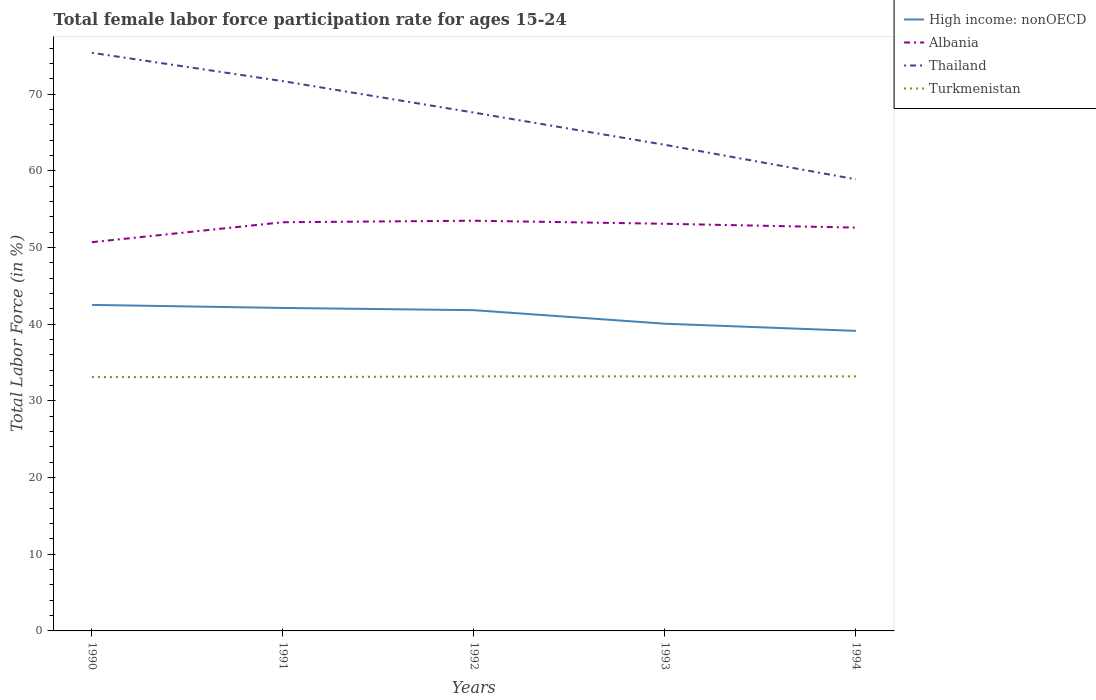How many different coloured lines are there?
Keep it short and to the point. 4. Does the line corresponding to High income: nonOECD intersect with the line corresponding to Albania?
Your answer should be compact. No. Is the number of lines equal to the number of legend labels?
Your answer should be very brief. Yes. Across all years, what is the maximum female labor force participation rate in High income: nonOECD?
Make the answer very short. 39.13. In which year was the female labor force participation rate in Thailand maximum?
Offer a very short reply. 1994. What is the total female labor force participation rate in Thailand in the graph?
Keep it short and to the point. 12. What is the difference between the highest and the second highest female labor force participation rate in Albania?
Give a very brief answer. 2.8. What is the difference between the highest and the lowest female labor force participation rate in Turkmenistan?
Offer a very short reply. 3. Is the female labor force participation rate in Albania strictly greater than the female labor force participation rate in Turkmenistan over the years?
Make the answer very short. No. How many years are there in the graph?
Provide a succinct answer. 5. How many legend labels are there?
Give a very brief answer. 4. What is the title of the graph?
Offer a terse response. Total female labor force participation rate for ages 15-24. Does "Saudi Arabia" appear as one of the legend labels in the graph?
Make the answer very short. No. What is the Total Labor Force (in %) of High income: nonOECD in 1990?
Offer a very short reply. 42.52. What is the Total Labor Force (in %) of Albania in 1990?
Ensure brevity in your answer.  50.7. What is the Total Labor Force (in %) in Thailand in 1990?
Offer a very short reply. 75.4. What is the Total Labor Force (in %) in Turkmenistan in 1990?
Your response must be concise. 33.1. What is the Total Labor Force (in %) in High income: nonOECD in 1991?
Your answer should be compact. 42.12. What is the Total Labor Force (in %) of Albania in 1991?
Offer a terse response. 53.3. What is the Total Labor Force (in %) of Thailand in 1991?
Your response must be concise. 71.7. What is the Total Labor Force (in %) in Turkmenistan in 1991?
Keep it short and to the point. 33.1. What is the Total Labor Force (in %) of High income: nonOECD in 1992?
Offer a very short reply. 41.83. What is the Total Labor Force (in %) in Albania in 1992?
Provide a succinct answer. 53.5. What is the Total Labor Force (in %) of Thailand in 1992?
Ensure brevity in your answer.  67.6. What is the Total Labor Force (in %) in Turkmenistan in 1992?
Give a very brief answer. 33.2. What is the Total Labor Force (in %) in High income: nonOECD in 1993?
Ensure brevity in your answer.  40.07. What is the Total Labor Force (in %) in Albania in 1993?
Give a very brief answer. 53.1. What is the Total Labor Force (in %) of Thailand in 1993?
Ensure brevity in your answer.  63.4. What is the Total Labor Force (in %) in Turkmenistan in 1993?
Your answer should be very brief. 33.2. What is the Total Labor Force (in %) in High income: nonOECD in 1994?
Your answer should be very brief. 39.13. What is the Total Labor Force (in %) of Albania in 1994?
Give a very brief answer. 52.6. What is the Total Labor Force (in %) of Thailand in 1994?
Offer a very short reply. 58.9. What is the Total Labor Force (in %) of Turkmenistan in 1994?
Give a very brief answer. 33.2. Across all years, what is the maximum Total Labor Force (in %) of High income: nonOECD?
Make the answer very short. 42.52. Across all years, what is the maximum Total Labor Force (in %) of Albania?
Make the answer very short. 53.5. Across all years, what is the maximum Total Labor Force (in %) of Thailand?
Your response must be concise. 75.4. Across all years, what is the maximum Total Labor Force (in %) of Turkmenistan?
Offer a terse response. 33.2. Across all years, what is the minimum Total Labor Force (in %) in High income: nonOECD?
Offer a terse response. 39.13. Across all years, what is the minimum Total Labor Force (in %) of Albania?
Ensure brevity in your answer.  50.7. Across all years, what is the minimum Total Labor Force (in %) in Thailand?
Provide a succinct answer. 58.9. Across all years, what is the minimum Total Labor Force (in %) of Turkmenistan?
Your answer should be very brief. 33.1. What is the total Total Labor Force (in %) of High income: nonOECD in the graph?
Offer a very short reply. 205.67. What is the total Total Labor Force (in %) in Albania in the graph?
Offer a terse response. 263.2. What is the total Total Labor Force (in %) in Thailand in the graph?
Give a very brief answer. 337. What is the total Total Labor Force (in %) in Turkmenistan in the graph?
Provide a short and direct response. 165.8. What is the difference between the Total Labor Force (in %) in High income: nonOECD in 1990 and that in 1991?
Provide a succinct answer. 0.39. What is the difference between the Total Labor Force (in %) in Thailand in 1990 and that in 1991?
Your answer should be compact. 3.7. What is the difference between the Total Labor Force (in %) of Turkmenistan in 1990 and that in 1991?
Your answer should be compact. 0. What is the difference between the Total Labor Force (in %) in High income: nonOECD in 1990 and that in 1992?
Your answer should be compact. 0.69. What is the difference between the Total Labor Force (in %) of Albania in 1990 and that in 1992?
Keep it short and to the point. -2.8. What is the difference between the Total Labor Force (in %) in High income: nonOECD in 1990 and that in 1993?
Your response must be concise. 2.45. What is the difference between the Total Labor Force (in %) in High income: nonOECD in 1990 and that in 1994?
Provide a succinct answer. 3.39. What is the difference between the Total Labor Force (in %) in Thailand in 1990 and that in 1994?
Offer a very short reply. 16.5. What is the difference between the Total Labor Force (in %) in High income: nonOECD in 1991 and that in 1992?
Provide a short and direct response. 0.29. What is the difference between the Total Labor Force (in %) in Thailand in 1991 and that in 1992?
Provide a short and direct response. 4.1. What is the difference between the Total Labor Force (in %) of Turkmenistan in 1991 and that in 1992?
Your answer should be very brief. -0.1. What is the difference between the Total Labor Force (in %) in High income: nonOECD in 1991 and that in 1993?
Provide a succinct answer. 2.06. What is the difference between the Total Labor Force (in %) in Albania in 1991 and that in 1993?
Ensure brevity in your answer.  0.2. What is the difference between the Total Labor Force (in %) in Thailand in 1991 and that in 1993?
Make the answer very short. 8.3. What is the difference between the Total Labor Force (in %) in High income: nonOECD in 1991 and that in 1994?
Give a very brief answer. 2.99. What is the difference between the Total Labor Force (in %) of Thailand in 1991 and that in 1994?
Offer a terse response. 12.8. What is the difference between the Total Labor Force (in %) in High income: nonOECD in 1992 and that in 1993?
Ensure brevity in your answer.  1.77. What is the difference between the Total Labor Force (in %) in Albania in 1992 and that in 1993?
Give a very brief answer. 0.4. What is the difference between the Total Labor Force (in %) of Turkmenistan in 1992 and that in 1993?
Your answer should be very brief. 0. What is the difference between the Total Labor Force (in %) of High income: nonOECD in 1992 and that in 1994?
Ensure brevity in your answer.  2.7. What is the difference between the Total Labor Force (in %) of Thailand in 1992 and that in 1994?
Offer a terse response. 8.7. What is the difference between the Total Labor Force (in %) in High income: nonOECD in 1993 and that in 1994?
Provide a succinct answer. 0.93. What is the difference between the Total Labor Force (in %) in Albania in 1993 and that in 1994?
Provide a short and direct response. 0.5. What is the difference between the Total Labor Force (in %) in Thailand in 1993 and that in 1994?
Your answer should be very brief. 4.5. What is the difference between the Total Labor Force (in %) in Turkmenistan in 1993 and that in 1994?
Your response must be concise. 0. What is the difference between the Total Labor Force (in %) of High income: nonOECD in 1990 and the Total Labor Force (in %) of Albania in 1991?
Provide a short and direct response. -10.78. What is the difference between the Total Labor Force (in %) of High income: nonOECD in 1990 and the Total Labor Force (in %) of Thailand in 1991?
Give a very brief answer. -29.18. What is the difference between the Total Labor Force (in %) of High income: nonOECD in 1990 and the Total Labor Force (in %) of Turkmenistan in 1991?
Provide a succinct answer. 9.42. What is the difference between the Total Labor Force (in %) in Albania in 1990 and the Total Labor Force (in %) in Thailand in 1991?
Provide a succinct answer. -21. What is the difference between the Total Labor Force (in %) in Thailand in 1990 and the Total Labor Force (in %) in Turkmenistan in 1991?
Offer a very short reply. 42.3. What is the difference between the Total Labor Force (in %) in High income: nonOECD in 1990 and the Total Labor Force (in %) in Albania in 1992?
Provide a succinct answer. -10.98. What is the difference between the Total Labor Force (in %) of High income: nonOECD in 1990 and the Total Labor Force (in %) of Thailand in 1992?
Your response must be concise. -25.08. What is the difference between the Total Labor Force (in %) in High income: nonOECD in 1990 and the Total Labor Force (in %) in Turkmenistan in 1992?
Ensure brevity in your answer.  9.32. What is the difference between the Total Labor Force (in %) of Albania in 1990 and the Total Labor Force (in %) of Thailand in 1992?
Your answer should be very brief. -16.9. What is the difference between the Total Labor Force (in %) in Albania in 1990 and the Total Labor Force (in %) in Turkmenistan in 1992?
Your answer should be compact. 17.5. What is the difference between the Total Labor Force (in %) in Thailand in 1990 and the Total Labor Force (in %) in Turkmenistan in 1992?
Your response must be concise. 42.2. What is the difference between the Total Labor Force (in %) in High income: nonOECD in 1990 and the Total Labor Force (in %) in Albania in 1993?
Make the answer very short. -10.58. What is the difference between the Total Labor Force (in %) of High income: nonOECD in 1990 and the Total Labor Force (in %) of Thailand in 1993?
Offer a very short reply. -20.88. What is the difference between the Total Labor Force (in %) in High income: nonOECD in 1990 and the Total Labor Force (in %) in Turkmenistan in 1993?
Make the answer very short. 9.32. What is the difference between the Total Labor Force (in %) in Albania in 1990 and the Total Labor Force (in %) in Thailand in 1993?
Provide a short and direct response. -12.7. What is the difference between the Total Labor Force (in %) in Thailand in 1990 and the Total Labor Force (in %) in Turkmenistan in 1993?
Keep it short and to the point. 42.2. What is the difference between the Total Labor Force (in %) of High income: nonOECD in 1990 and the Total Labor Force (in %) of Albania in 1994?
Your response must be concise. -10.08. What is the difference between the Total Labor Force (in %) in High income: nonOECD in 1990 and the Total Labor Force (in %) in Thailand in 1994?
Give a very brief answer. -16.38. What is the difference between the Total Labor Force (in %) of High income: nonOECD in 1990 and the Total Labor Force (in %) of Turkmenistan in 1994?
Offer a very short reply. 9.32. What is the difference between the Total Labor Force (in %) of Albania in 1990 and the Total Labor Force (in %) of Thailand in 1994?
Make the answer very short. -8.2. What is the difference between the Total Labor Force (in %) in Thailand in 1990 and the Total Labor Force (in %) in Turkmenistan in 1994?
Provide a short and direct response. 42.2. What is the difference between the Total Labor Force (in %) in High income: nonOECD in 1991 and the Total Labor Force (in %) in Albania in 1992?
Offer a very short reply. -11.38. What is the difference between the Total Labor Force (in %) in High income: nonOECD in 1991 and the Total Labor Force (in %) in Thailand in 1992?
Provide a succinct answer. -25.48. What is the difference between the Total Labor Force (in %) in High income: nonOECD in 1991 and the Total Labor Force (in %) in Turkmenistan in 1992?
Offer a very short reply. 8.92. What is the difference between the Total Labor Force (in %) in Albania in 1991 and the Total Labor Force (in %) in Thailand in 1992?
Ensure brevity in your answer.  -14.3. What is the difference between the Total Labor Force (in %) of Albania in 1991 and the Total Labor Force (in %) of Turkmenistan in 1992?
Give a very brief answer. 20.1. What is the difference between the Total Labor Force (in %) of Thailand in 1991 and the Total Labor Force (in %) of Turkmenistan in 1992?
Provide a short and direct response. 38.5. What is the difference between the Total Labor Force (in %) of High income: nonOECD in 1991 and the Total Labor Force (in %) of Albania in 1993?
Keep it short and to the point. -10.98. What is the difference between the Total Labor Force (in %) in High income: nonOECD in 1991 and the Total Labor Force (in %) in Thailand in 1993?
Offer a very short reply. -21.28. What is the difference between the Total Labor Force (in %) in High income: nonOECD in 1991 and the Total Labor Force (in %) in Turkmenistan in 1993?
Keep it short and to the point. 8.92. What is the difference between the Total Labor Force (in %) in Albania in 1991 and the Total Labor Force (in %) in Turkmenistan in 1993?
Provide a short and direct response. 20.1. What is the difference between the Total Labor Force (in %) in Thailand in 1991 and the Total Labor Force (in %) in Turkmenistan in 1993?
Keep it short and to the point. 38.5. What is the difference between the Total Labor Force (in %) of High income: nonOECD in 1991 and the Total Labor Force (in %) of Albania in 1994?
Provide a succinct answer. -10.48. What is the difference between the Total Labor Force (in %) in High income: nonOECD in 1991 and the Total Labor Force (in %) in Thailand in 1994?
Your answer should be compact. -16.78. What is the difference between the Total Labor Force (in %) in High income: nonOECD in 1991 and the Total Labor Force (in %) in Turkmenistan in 1994?
Keep it short and to the point. 8.92. What is the difference between the Total Labor Force (in %) of Albania in 1991 and the Total Labor Force (in %) of Thailand in 1994?
Offer a terse response. -5.6. What is the difference between the Total Labor Force (in %) in Albania in 1991 and the Total Labor Force (in %) in Turkmenistan in 1994?
Offer a terse response. 20.1. What is the difference between the Total Labor Force (in %) of Thailand in 1991 and the Total Labor Force (in %) of Turkmenistan in 1994?
Keep it short and to the point. 38.5. What is the difference between the Total Labor Force (in %) of High income: nonOECD in 1992 and the Total Labor Force (in %) of Albania in 1993?
Keep it short and to the point. -11.27. What is the difference between the Total Labor Force (in %) of High income: nonOECD in 1992 and the Total Labor Force (in %) of Thailand in 1993?
Your answer should be compact. -21.57. What is the difference between the Total Labor Force (in %) of High income: nonOECD in 1992 and the Total Labor Force (in %) of Turkmenistan in 1993?
Your answer should be very brief. 8.63. What is the difference between the Total Labor Force (in %) in Albania in 1992 and the Total Labor Force (in %) in Turkmenistan in 1993?
Offer a terse response. 20.3. What is the difference between the Total Labor Force (in %) in Thailand in 1992 and the Total Labor Force (in %) in Turkmenistan in 1993?
Provide a succinct answer. 34.4. What is the difference between the Total Labor Force (in %) in High income: nonOECD in 1992 and the Total Labor Force (in %) in Albania in 1994?
Ensure brevity in your answer.  -10.77. What is the difference between the Total Labor Force (in %) in High income: nonOECD in 1992 and the Total Labor Force (in %) in Thailand in 1994?
Keep it short and to the point. -17.07. What is the difference between the Total Labor Force (in %) in High income: nonOECD in 1992 and the Total Labor Force (in %) in Turkmenistan in 1994?
Your answer should be compact. 8.63. What is the difference between the Total Labor Force (in %) in Albania in 1992 and the Total Labor Force (in %) in Turkmenistan in 1994?
Offer a terse response. 20.3. What is the difference between the Total Labor Force (in %) in Thailand in 1992 and the Total Labor Force (in %) in Turkmenistan in 1994?
Ensure brevity in your answer.  34.4. What is the difference between the Total Labor Force (in %) of High income: nonOECD in 1993 and the Total Labor Force (in %) of Albania in 1994?
Provide a short and direct response. -12.53. What is the difference between the Total Labor Force (in %) in High income: nonOECD in 1993 and the Total Labor Force (in %) in Thailand in 1994?
Ensure brevity in your answer.  -18.83. What is the difference between the Total Labor Force (in %) in High income: nonOECD in 1993 and the Total Labor Force (in %) in Turkmenistan in 1994?
Keep it short and to the point. 6.87. What is the difference between the Total Labor Force (in %) in Albania in 1993 and the Total Labor Force (in %) in Turkmenistan in 1994?
Your response must be concise. 19.9. What is the difference between the Total Labor Force (in %) of Thailand in 1993 and the Total Labor Force (in %) of Turkmenistan in 1994?
Your response must be concise. 30.2. What is the average Total Labor Force (in %) in High income: nonOECD per year?
Offer a terse response. 41.13. What is the average Total Labor Force (in %) in Albania per year?
Give a very brief answer. 52.64. What is the average Total Labor Force (in %) in Thailand per year?
Your answer should be very brief. 67.4. What is the average Total Labor Force (in %) in Turkmenistan per year?
Keep it short and to the point. 33.16. In the year 1990, what is the difference between the Total Labor Force (in %) of High income: nonOECD and Total Labor Force (in %) of Albania?
Keep it short and to the point. -8.18. In the year 1990, what is the difference between the Total Labor Force (in %) of High income: nonOECD and Total Labor Force (in %) of Thailand?
Your answer should be compact. -32.88. In the year 1990, what is the difference between the Total Labor Force (in %) of High income: nonOECD and Total Labor Force (in %) of Turkmenistan?
Your answer should be compact. 9.42. In the year 1990, what is the difference between the Total Labor Force (in %) of Albania and Total Labor Force (in %) of Thailand?
Offer a terse response. -24.7. In the year 1990, what is the difference between the Total Labor Force (in %) of Albania and Total Labor Force (in %) of Turkmenistan?
Your answer should be very brief. 17.6. In the year 1990, what is the difference between the Total Labor Force (in %) of Thailand and Total Labor Force (in %) of Turkmenistan?
Provide a succinct answer. 42.3. In the year 1991, what is the difference between the Total Labor Force (in %) in High income: nonOECD and Total Labor Force (in %) in Albania?
Your answer should be very brief. -11.18. In the year 1991, what is the difference between the Total Labor Force (in %) of High income: nonOECD and Total Labor Force (in %) of Thailand?
Provide a short and direct response. -29.58. In the year 1991, what is the difference between the Total Labor Force (in %) in High income: nonOECD and Total Labor Force (in %) in Turkmenistan?
Offer a very short reply. 9.02. In the year 1991, what is the difference between the Total Labor Force (in %) of Albania and Total Labor Force (in %) of Thailand?
Your response must be concise. -18.4. In the year 1991, what is the difference between the Total Labor Force (in %) of Albania and Total Labor Force (in %) of Turkmenistan?
Give a very brief answer. 20.2. In the year 1991, what is the difference between the Total Labor Force (in %) of Thailand and Total Labor Force (in %) of Turkmenistan?
Ensure brevity in your answer.  38.6. In the year 1992, what is the difference between the Total Labor Force (in %) in High income: nonOECD and Total Labor Force (in %) in Albania?
Your response must be concise. -11.67. In the year 1992, what is the difference between the Total Labor Force (in %) in High income: nonOECD and Total Labor Force (in %) in Thailand?
Offer a terse response. -25.77. In the year 1992, what is the difference between the Total Labor Force (in %) in High income: nonOECD and Total Labor Force (in %) in Turkmenistan?
Offer a terse response. 8.63. In the year 1992, what is the difference between the Total Labor Force (in %) in Albania and Total Labor Force (in %) in Thailand?
Offer a terse response. -14.1. In the year 1992, what is the difference between the Total Labor Force (in %) of Albania and Total Labor Force (in %) of Turkmenistan?
Your answer should be very brief. 20.3. In the year 1992, what is the difference between the Total Labor Force (in %) of Thailand and Total Labor Force (in %) of Turkmenistan?
Your answer should be compact. 34.4. In the year 1993, what is the difference between the Total Labor Force (in %) of High income: nonOECD and Total Labor Force (in %) of Albania?
Provide a succinct answer. -13.03. In the year 1993, what is the difference between the Total Labor Force (in %) of High income: nonOECD and Total Labor Force (in %) of Thailand?
Provide a succinct answer. -23.33. In the year 1993, what is the difference between the Total Labor Force (in %) in High income: nonOECD and Total Labor Force (in %) in Turkmenistan?
Your answer should be very brief. 6.87. In the year 1993, what is the difference between the Total Labor Force (in %) in Albania and Total Labor Force (in %) in Thailand?
Your response must be concise. -10.3. In the year 1993, what is the difference between the Total Labor Force (in %) in Thailand and Total Labor Force (in %) in Turkmenistan?
Provide a succinct answer. 30.2. In the year 1994, what is the difference between the Total Labor Force (in %) of High income: nonOECD and Total Labor Force (in %) of Albania?
Your response must be concise. -13.47. In the year 1994, what is the difference between the Total Labor Force (in %) of High income: nonOECD and Total Labor Force (in %) of Thailand?
Your answer should be compact. -19.77. In the year 1994, what is the difference between the Total Labor Force (in %) of High income: nonOECD and Total Labor Force (in %) of Turkmenistan?
Make the answer very short. 5.93. In the year 1994, what is the difference between the Total Labor Force (in %) of Albania and Total Labor Force (in %) of Thailand?
Offer a very short reply. -6.3. In the year 1994, what is the difference between the Total Labor Force (in %) in Albania and Total Labor Force (in %) in Turkmenistan?
Ensure brevity in your answer.  19.4. In the year 1994, what is the difference between the Total Labor Force (in %) of Thailand and Total Labor Force (in %) of Turkmenistan?
Offer a terse response. 25.7. What is the ratio of the Total Labor Force (in %) in High income: nonOECD in 1990 to that in 1991?
Provide a short and direct response. 1.01. What is the ratio of the Total Labor Force (in %) in Albania in 1990 to that in 1991?
Provide a short and direct response. 0.95. What is the ratio of the Total Labor Force (in %) in Thailand in 1990 to that in 1991?
Make the answer very short. 1.05. What is the ratio of the Total Labor Force (in %) of Turkmenistan in 1990 to that in 1991?
Offer a terse response. 1. What is the ratio of the Total Labor Force (in %) in High income: nonOECD in 1990 to that in 1992?
Make the answer very short. 1.02. What is the ratio of the Total Labor Force (in %) in Albania in 1990 to that in 1992?
Offer a terse response. 0.95. What is the ratio of the Total Labor Force (in %) of Thailand in 1990 to that in 1992?
Make the answer very short. 1.12. What is the ratio of the Total Labor Force (in %) of High income: nonOECD in 1990 to that in 1993?
Offer a terse response. 1.06. What is the ratio of the Total Labor Force (in %) in Albania in 1990 to that in 1993?
Your answer should be very brief. 0.95. What is the ratio of the Total Labor Force (in %) in Thailand in 1990 to that in 1993?
Your answer should be compact. 1.19. What is the ratio of the Total Labor Force (in %) of Turkmenistan in 1990 to that in 1993?
Provide a short and direct response. 1. What is the ratio of the Total Labor Force (in %) in High income: nonOECD in 1990 to that in 1994?
Your response must be concise. 1.09. What is the ratio of the Total Labor Force (in %) in Albania in 1990 to that in 1994?
Make the answer very short. 0.96. What is the ratio of the Total Labor Force (in %) of Thailand in 1990 to that in 1994?
Offer a terse response. 1.28. What is the ratio of the Total Labor Force (in %) of High income: nonOECD in 1991 to that in 1992?
Keep it short and to the point. 1.01. What is the ratio of the Total Labor Force (in %) in Thailand in 1991 to that in 1992?
Provide a succinct answer. 1.06. What is the ratio of the Total Labor Force (in %) in High income: nonOECD in 1991 to that in 1993?
Provide a short and direct response. 1.05. What is the ratio of the Total Labor Force (in %) of Albania in 1991 to that in 1993?
Offer a terse response. 1. What is the ratio of the Total Labor Force (in %) of Thailand in 1991 to that in 1993?
Provide a short and direct response. 1.13. What is the ratio of the Total Labor Force (in %) of Turkmenistan in 1991 to that in 1993?
Provide a short and direct response. 1. What is the ratio of the Total Labor Force (in %) of High income: nonOECD in 1991 to that in 1994?
Ensure brevity in your answer.  1.08. What is the ratio of the Total Labor Force (in %) of Albania in 1991 to that in 1994?
Give a very brief answer. 1.01. What is the ratio of the Total Labor Force (in %) in Thailand in 1991 to that in 1994?
Your answer should be very brief. 1.22. What is the ratio of the Total Labor Force (in %) of Turkmenistan in 1991 to that in 1994?
Ensure brevity in your answer.  1. What is the ratio of the Total Labor Force (in %) in High income: nonOECD in 1992 to that in 1993?
Provide a short and direct response. 1.04. What is the ratio of the Total Labor Force (in %) of Albania in 1992 to that in 1993?
Your answer should be very brief. 1.01. What is the ratio of the Total Labor Force (in %) in Thailand in 1992 to that in 1993?
Your answer should be compact. 1.07. What is the ratio of the Total Labor Force (in %) of High income: nonOECD in 1992 to that in 1994?
Your answer should be very brief. 1.07. What is the ratio of the Total Labor Force (in %) in Albania in 1992 to that in 1994?
Your response must be concise. 1.02. What is the ratio of the Total Labor Force (in %) of Thailand in 1992 to that in 1994?
Make the answer very short. 1.15. What is the ratio of the Total Labor Force (in %) in High income: nonOECD in 1993 to that in 1994?
Ensure brevity in your answer.  1.02. What is the ratio of the Total Labor Force (in %) in Albania in 1993 to that in 1994?
Keep it short and to the point. 1.01. What is the ratio of the Total Labor Force (in %) of Thailand in 1993 to that in 1994?
Give a very brief answer. 1.08. What is the difference between the highest and the second highest Total Labor Force (in %) of High income: nonOECD?
Your response must be concise. 0.39. What is the difference between the highest and the lowest Total Labor Force (in %) in High income: nonOECD?
Offer a terse response. 3.39. What is the difference between the highest and the lowest Total Labor Force (in %) of Albania?
Provide a short and direct response. 2.8. What is the difference between the highest and the lowest Total Labor Force (in %) of Turkmenistan?
Your answer should be compact. 0.1. 